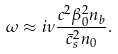Convert formula to latex. <formula><loc_0><loc_0><loc_500><loc_500>\omega \approx i \nu \frac { c ^ { 2 } \beta _ { 0 } ^ { 2 } n _ { b } } { \bar { c } _ { s } ^ { 2 } n _ { 0 } } .</formula> 